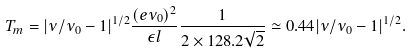<formula> <loc_0><loc_0><loc_500><loc_500>T _ { m } = | \nu / \nu _ { 0 } - 1 | ^ { 1 / 2 } \frac { ( e \nu _ { 0 } ) ^ { 2 } } { \epsilon l } \frac { 1 } { 2 \times 1 2 8 . 2 \sqrt { 2 } } \simeq 0 . 4 4 | \nu / \nu _ { 0 } - 1 | ^ { 1 / 2 } .</formula> 